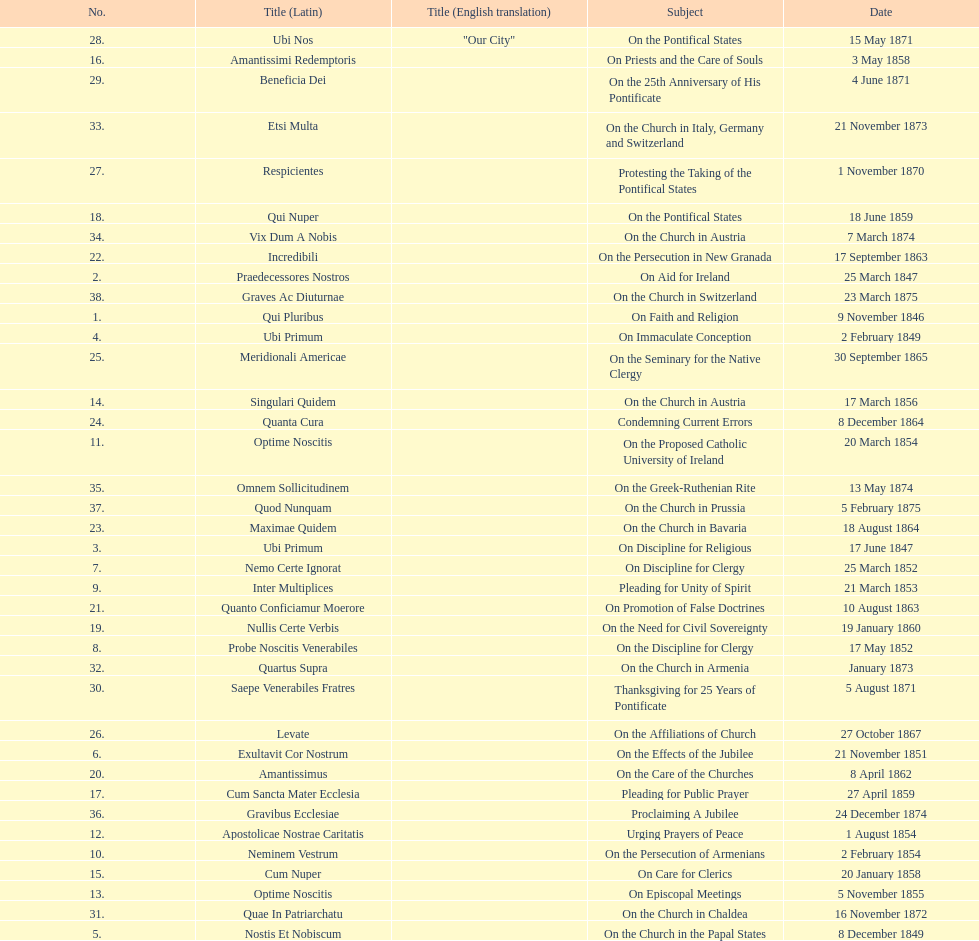How often was an encyclical sent in january? 3. 